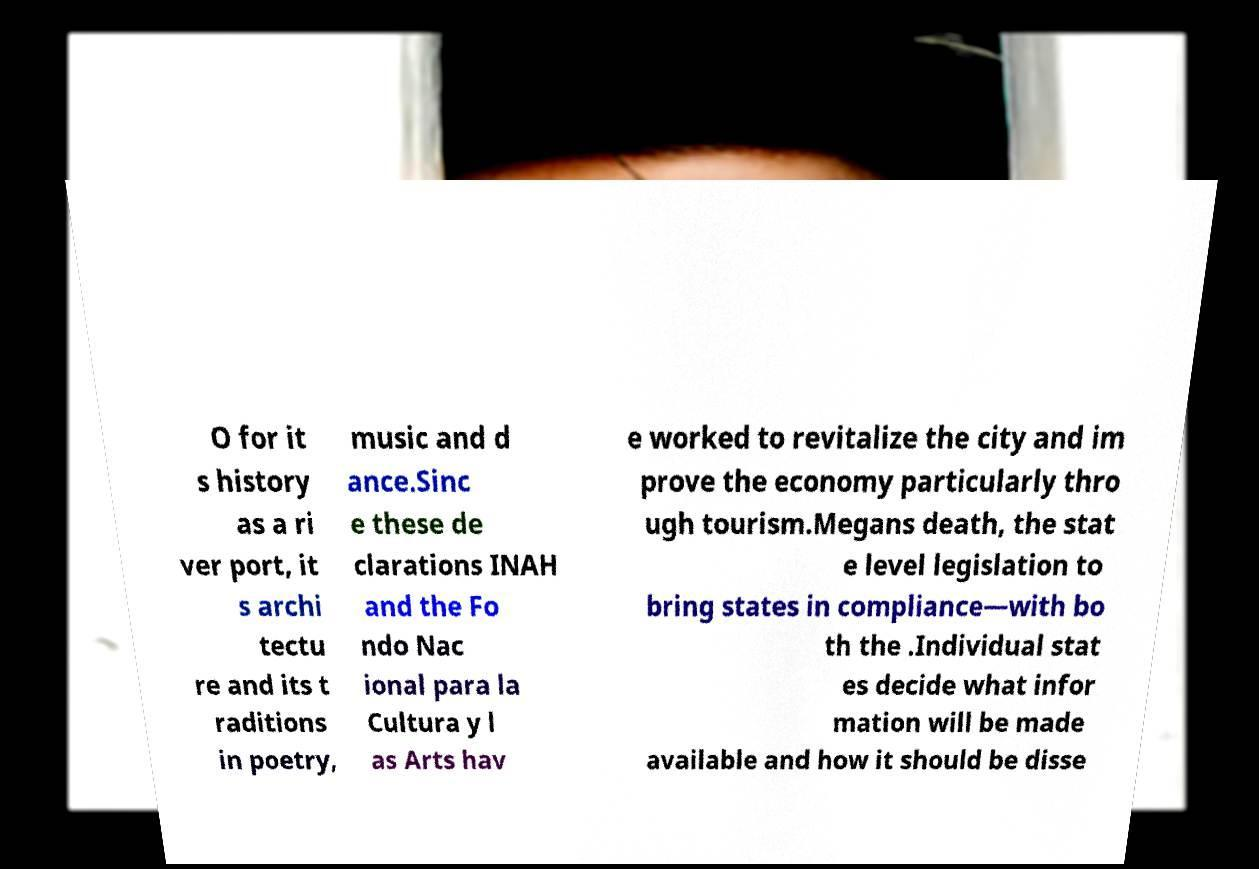Can you read and provide the text displayed in the image?This photo seems to have some interesting text. Can you extract and type it out for me? O for it s history as a ri ver port, it s archi tectu re and its t raditions in poetry, music and d ance.Sinc e these de clarations INAH and the Fo ndo Nac ional para la Cultura y l as Arts hav e worked to revitalize the city and im prove the economy particularly thro ugh tourism.Megans death, the stat e level legislation to bring states in compliance—with bo th the .Individual stat es decide what infor mation will be made available and how it should be disse 